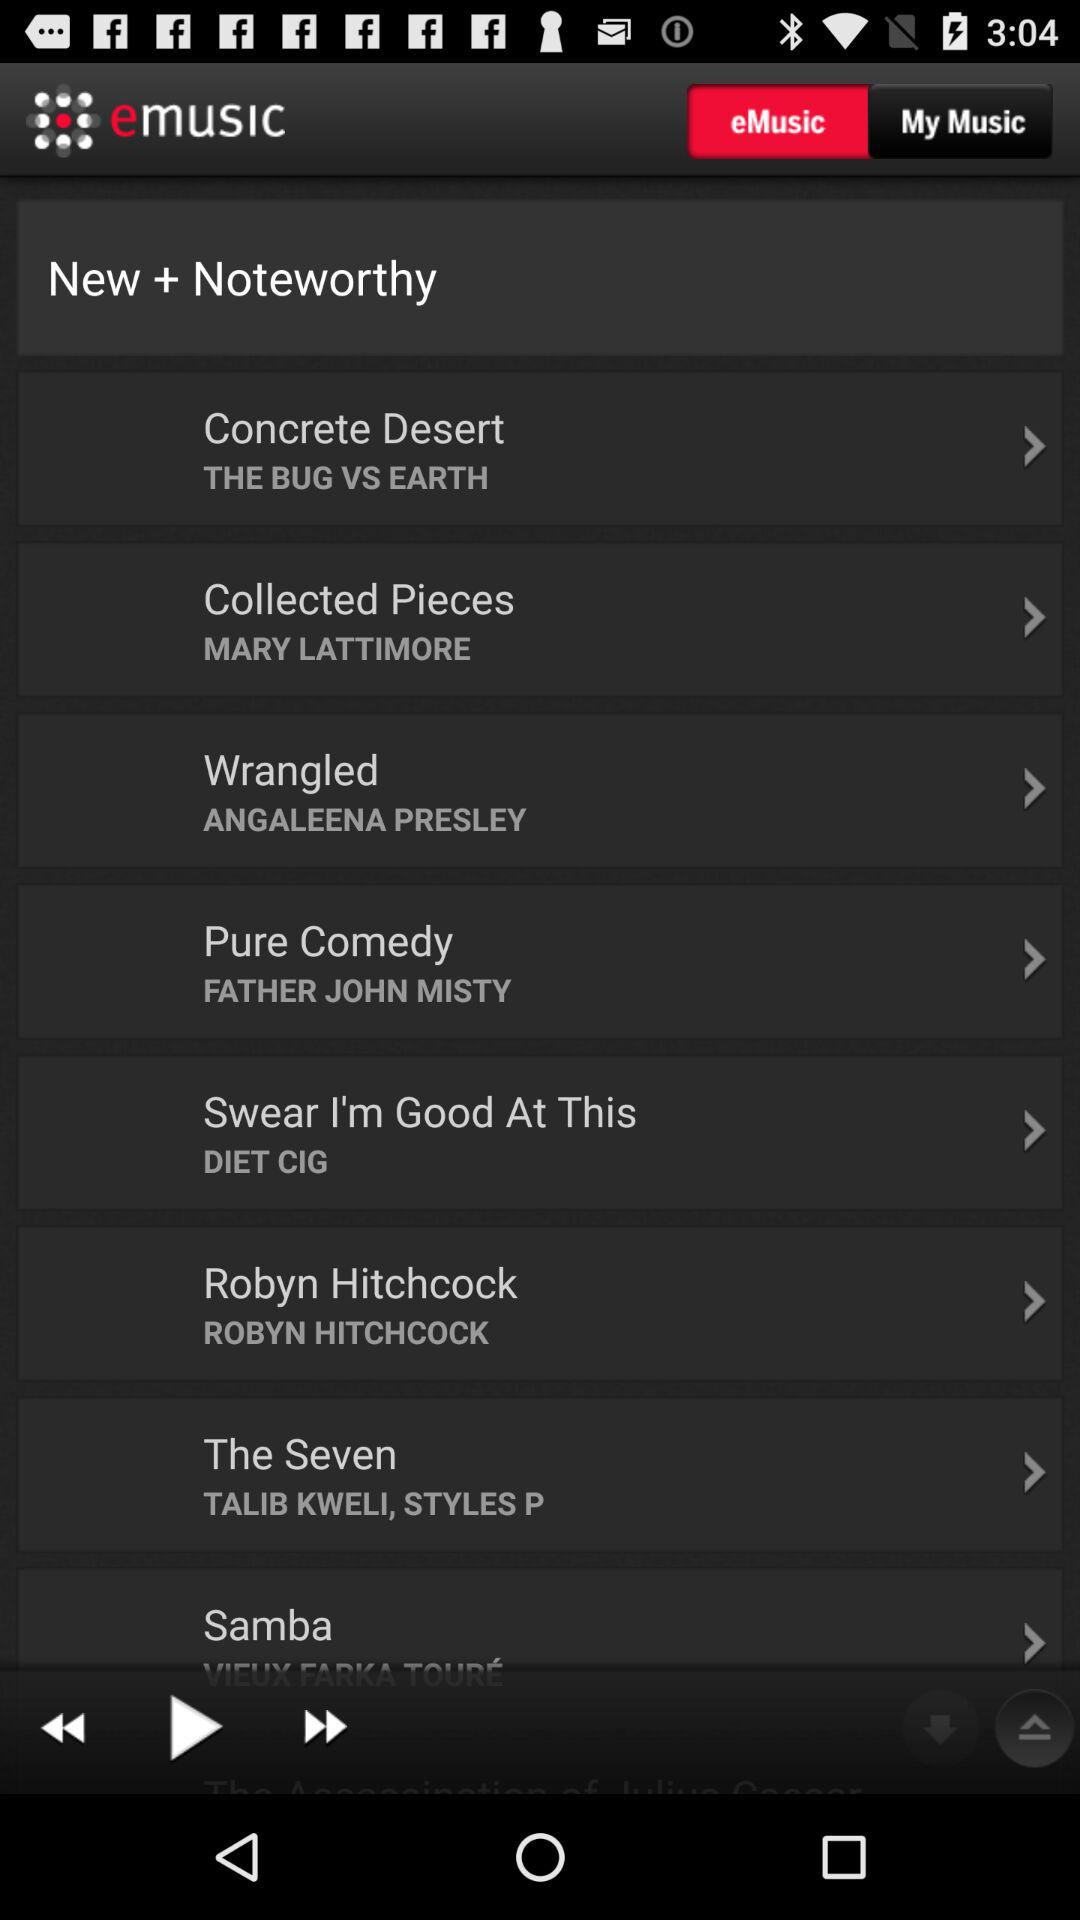What is the name of the application? The name of the application is "emusic". 